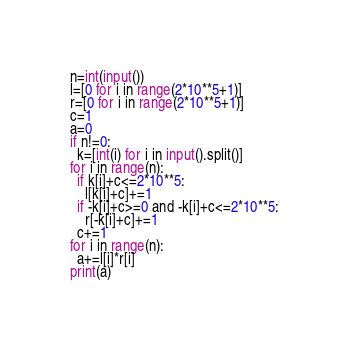Convert code to text. <code><loc_0><loc_0><loc_500><loc_500><_Python_>n=int(input())
l=[0 for i in range(2*10**5+1)]
r=[0 for i in range(2*10**5+1)]
c=1
a=0
if n!=0:
  k=[int(i) for i in input().split()]
for i in range(n):
  if k[i]+c<=2*10**5:
    l[k[i]+c]+=1 
  if -k[i]+c>=0 and -k[i]+c<=2*10**5:
    r[-k[i]+c]+=1
  c+=1
for i in range(n):
  a+=l[i]*r[i]
print(a)
</code> 